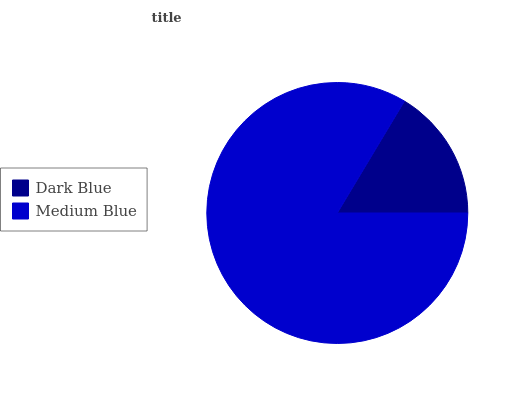Is Dark Blue the minimum?
Answer yes or no. Yes. Is Medium Blue the maximum?
Answer yes or no. Yes. Is Medium Blue the minimum?
Answer yes or no. No. Is Medium Blue greater than Dark Blue?
Answer yes or no. Yes. Is Dark Blue less than Medium Blue?
Answer yes or no. Yes. Is Dark Blue greater than Medium Blue?
Answer yes or no. No. Is Medium Blue less than Dark Blue?
Answer yes or no. No. Is Medium Blue the high median?
Answer yes or no. Yes. Is Dark Blue the low median?
Answer yes or no. Yes. Is Dark Blue the high median?
Answer yes or no. No. Is Medium Blue the low median?
Answer yes or no. No. 